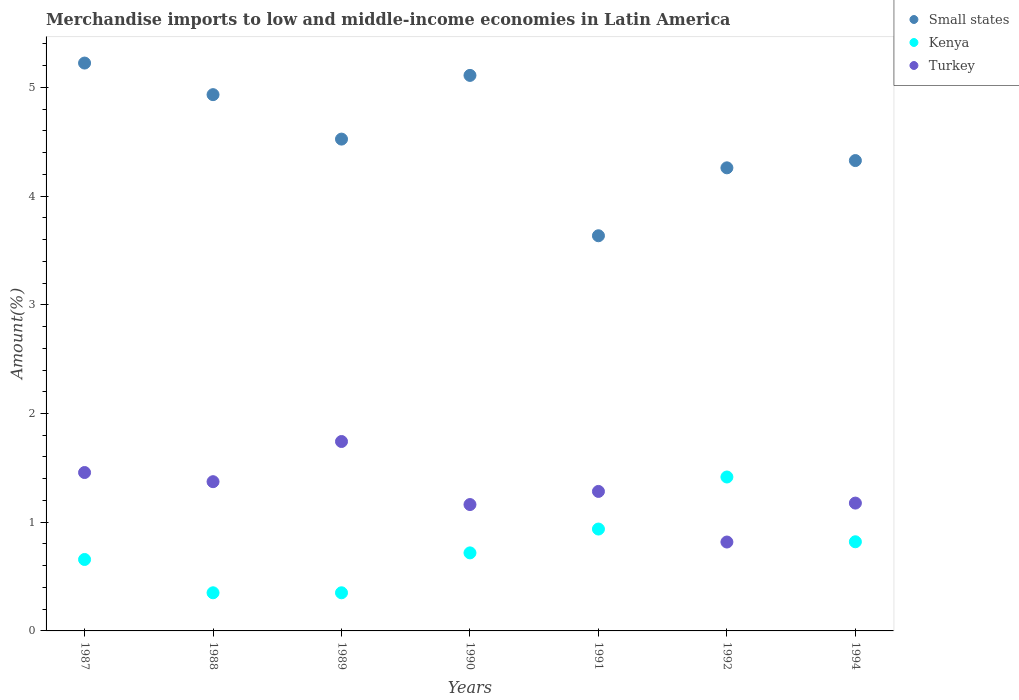How many different coloured dotlines are there?
Keep it short and to the point. 3. Is the number of dotlines equal to the number of legend labels?
Give a very brief answer. Yes. What is the percentage of amount earned from merchandise imports in Turkey in 1991?
Make the answer very short. 1.28. Across all years, what is the maximum percentage of amount earned from merchandise imports in Small states?
Your answer should be very brief. 5.22. Across all years, what is the minimum percentage of amount earned from merchandise imports in Turkey?
Your response must be concise. 0.82. In which year was the percentage of amount earned from merchandise imports in Turkey maximum?
Your answer should be compact. 1989. In which year was the percentage of amount earned from merchandise imports in Kenya minimum?
Keep it short and to the point. 1988. What is the total percentage of amount earned from merchandise imports in Kenya in the graph?
Provide a short and direct response. 5.25. What is the difference between the percentage of amount earned from merchandise imports in Kenya in 1987 and that in 1989?
Make the answer very short. 0.31. What is the difference between the percentage of amount earned from merchandise imports in Turkey in 1994 and the percentage of amount earned from merchandise imports in Kenya in 1990?
Give a very brief answer. 0.46. What is the average percentage of amount earned from merchandise imports in Kenya per year?
Offer a terse response. 0.75. In the year 1991, what is the difference between the percentage of amount earned from merchandise imports in Turkey and percentage of amount earned from merchandise imports in Small states?
Make the answer very short. -2.35. What is the ratio of the percentage of amount earned from merchandise imports in Turkey in 1990 to that in 1992?
Give a very brief answer. 1.42. Is the percentage of amount earned from merchandise imports in Kenya in 1987 less than that in 1989?
Ensure brevity in your answer.  No. What is the difference between the highest and the second highest percentage of amount earned from merchandise imports in Small states?
Offer a terse response. 0.11. What is the difference between the highest and the lowest percentage of amount earned from merchandise imports in Small states?
Keep it short and to the point. 1.59. Is the sum of the percentage of amount earned from merchandise imports in Small states in 1992 and 1994 greater than the maximum percentage of amount earned from merchandise imports in Kenya across all years?
Offer a terse response. Yes. Is it the case that in every year, the sum of the percentage of amount earned from merchandise imports in Kenya and percentage of amount earned from merchandise imports in Turkey  is greater than the percentage of amount earned from merchandise imports in Small states?
Offer a very short reply. No. Is the percentage of amount earned from merchandise imports in Kenya strictly greater than the percentage of amount earned from merchandise imports in Small states over the years?
Provide a succinct answer. No. What is the difference between two consecutive major ticks on the Y-axis?
Give a very brief answer. 1. Does the graph contain any zero values?
Offer a terse response. No. Where does the legend appear in the graph?
Offer a very short reply. Top right. How many legend labels are there?
Ensure brevity in your answer.  3. What is the title of the graph?
Provide a succinct answer. Merchandise imports to low and middle-income economies in Latin America. Does "French Polynesia" appear as one of the legend labels in the graph?
Your response must be concise. No. What is the label or title of the Y-axis?
Ensure brevity in your answer.  Amount(%). What is the Amount(%) of Small states in 1987?
Your response must be concise. 5.22. What is the Amount(%) in Kenya in 1987?
Ensure brevity in your answer.  0.66. What is the Amount(%) of Turkey in 1987?
Give a very brief answer. 1.46. What is the Amount(%) in Small states in 1988?
Provide a short and direct response. 4.93. What is the Amount(%) of Kenya in 1988?
Keep it short and to the point. 0.35. What is the Amount(%) of Turkey in 1988?
Offer a terse response. 1.37. What is the Amount(%) of Small states in 1989?
Offer a very short reply. 4.52. What is the Amount(%) of Kenya in 1989?
Give a very brief answer. 0.35. What is the Amount(%) in Turkey in 1989?
Provide a succinct answer. 1.74. What is the Amount(%) of Small states in 1990?
Provide a succinct answer. 5.11. What is the Amount(%) of Kenya in 1990?
Your response must be concise. 0.72. What is the Amount(%) in Turkey in 1990?
Offer a very short reply. 1.16. What is the Amount(%) of Small states in 1991?
Your response must be concise. 3.64. What is the Amount(%) in Kenya in 1991?
Your answer should be compact. 0.94. What is the Amount(%) of Turkey in 1991?
Provide a short and direct response. 1.28. What is the Amount(%) in Small states in 1992?
Your response must be concise. 4.26. What is the Amount(%) in Kenya in 1992?
Provide a short and direct response. 1.42. What is the Amount(%) of Turkey in 1992?
Your response must be concise. 0.82. What is the Amount(%) of Small states in 1994?
Make the answer very short. 4.33. What is the Amount(%) in Kenya in 1994?
Your answer should be very brief. 0.82. What is the Amount(%) in Turkey in 1994?
Offer a very short reply. 1.18. Across all years, what is the maximum Amount(%) in Small states?
Ensure brevity in your answer.  5.22. Across all years, what is the maximum Amount(%) of Kenya?
Your answer should be compact. 1.42. Across all years, what is the maximum Amount(%) of Turkey?
Your answer should be compact. 1.74. Across all years, what is the minimum Amount(%) of Small states?
Ensure brevity in your answer.  3.64. Across all years, what is the minimum Amount(%) of Kenya?
Provide a succinct answer. 0.35. Across all years, what is the minimum Amount(%) in Turkey?
Provide a short and direct response. 0.82. What is the total Amount(%) in Small states in the graph?
Provide a succinct answer. 32.01. What is the total Amount(%) of Kenya in the graph?
Keep it short and to the point. 5.25. What is the total Amount(%) of Turkey in the graph?
Provide a succinct answer. 9.01. What is the difference between the Amount(%) in Small states in 1987 and that in 1988?
Your answer should be very brief. 0.29. What is the difference between the Amount(%) of Kenya in 1987 and that in 1988?
Make the answer very short. 0.31. What is the difference between the Amount(%) of Turkey in 1987 and that in 1988?
Ensure brevity in your answer.  0.08. What is the difference between the Amount(%) in Small states in 1987 and that in 1989?
Give a very brief answer. 0.7. What is the difference between the Amount(%) in Kenya in 1987 and that in 1989?
Make the answer very short. 0.31. What is the difference between the Amount(%) in Turkey in 1987 and that in 1989?
Your response must be concise. -0.29. What is the difference between the Amount(%) in Small states in 1987 and that in 1990?
Keep it short and to the point. 0.11. What is the difference between the Amount(%) of Kenya in 1987 and that in 1990?
Keep it short and to the point. -0.06. What is the difference between the Amount(%) in Turkey in 1987 and that in 1990?
Your answer should be compact. 0.29. What is the difference between the Amount(%) of Small states in 1987 and that in 1991?
Your answer should be very brief. 1.59. What is the difference between the Amount(%) in Kenya in 1987 and that in 1991?
Give a very brief answer. -0.28. What is the difference between the Amount(%) of Turkey in 1987 and that in 1991?
Your answer should be compact. 0.17. What is the difference between the Amount(%) of Small states in 1987 and that in 1992?
Your answer should be compact. 0.96. What is the difference between the Amount(%) in Kenya in 1987 and that in 1992?
Offer a terse response. -0.76. What is the difference between the Amount(%) of Turkey in 1987 and that in 1992?
Make the answer very short. 0.64. What is the difference between the Amount(%) in Small states in 1987 and that in 1994?
Offer a very short reply. 0.9. What is the difference between the Amount(%) of Kenya in 1987 and that in 1994?
Make the answer very short. -0.16. What is the difference between the Amount(%) in Turkey in 1987 and that in 1994?
Offer a terse response. 0.28. What is the difference between the Amount(%) in Small states in 1988 and that in 1989?
Your answer should be very brief. 0.41. What is the difference between the Amount(%) of Kenya in 1988 and that in 1989?
Ensure brevity in your answer.  -0. What is the difference between the Amount(%) of Turkey in 1988 and that in 1989?
Offer a very short reply. -0.37. What is the difference between the Amount(%) of Small states in 1988 and that in 1990?
Keep it short and to the point. -0.18. What is the difference between the Amount(%) of Kenya in 1988 and that in 1990?
Give a very brief answer. -0.37. What is the difference between the Amount(%) of Turkey in 1988 and that in 1990?
Offer a terse response. 0.21. What is the difference between the Amount(%) in Small states in 1988 and that in 1991?
Your response must be concise. 1.3. What is the difference between the Amount(%) of Kenya in 1988 and that in 1991?
Ensure brevity in your answer.  -0.59. What is the difference between the Amount(%) of Turkey in 1988 and that in 1991?
Your answer should be compact. 0.09. What is the difference between the Amount(%) of Small states in 1988 and that in 1992?
Provide a short and direct response. 0.67. What is the difference between the Amount(%) in Kenya in 1988 and that in 1992?
Ensure brevity in your answer.  -1.07. What is the difference between the Amount(%) in Turkey in 1988 and that in 1992?
Make the answer very short. 0.56. What is the difference between the Amount(%) of Small states in 1988 and that in 1994?
Offer a terse response. 0.61. What is the difference between the Amount(%) of Kenya in 1988 and that in 1994?
Ensure brevity in your answer.  -0.47. What is the difference between the Amount(%) of Turkey in 1988 and that in 1994?
Make the answer very short. 0.2. What is the difference between the Amount(%) of Small states in 1989 and that in 1990?
Provide a succinct answer. -0.59. What is the difference between the Amount(%) of Kenya in 1989 and that in 1990?
Provide a succinct answer. -0.37. What is the difference between the Amount(%) of Turkey in 1989 and that in 1990?
Your answer should be compact. 0.58. What is the difference between the Amount(%) in Small states in 1989 and that in 1991?
Give a very brief answer. 0.89. What is the difference between the Amount(%) of Kenya in 1989 and that in 1991?
Give a very brief answer. -0.59. What is the difference between the Amount(%) of Turkey in 1989 and that in 1991?
Keep it short and to the point. 0.46. What is the difference between the Amount(%) in Small states in 1989 and that in 1992?
Give a very brief answer. 0.26. What is the difference between the Amount(%) of Kenya in 1989 and that in 1992?
Your response must be concise. -1.07. What is the difference between the Amount(%) in Turkey in 1989 and that in 1992?
Make the answer very short. 0.92. What is the difference between the Amount(%) of Small states in 1989 and that in 1994?
Your answer should be compact. 0.2. What is the difference between the Amount(%) in Kenya in 1989 and that in 1994?
Your response must be concise. -0.47. What is the difference between the Amount(%) of Turkey in 1989 and that in 1994?
Your answer should be compact. 0.57. What is the difference between the Amount(%) of Small states in 1990 and that in 1991?
Your response must be concise. 1.48. What is the difference between the Amount(%) of Kenya in 1990 and that in 1991?
Keep it short and to the point. -0.22. What is the difference between the Amount(%) of Turkey in 1990 and that in 1991?
Make the answer very short. -0.12. What is the difference between the Amount(%) in Small states in 1990 and that in 1992?
Provide a short and direct response. 0.85. What is the difference between the Amount(%) of Kenya in 1990 and that in 1992?
Ensure brevity in your answer.  -0.7. What is the difference between the Amount(%) in Turkey in 1990 and that in 1992?
Offer a very short reply. 0.34. What is the difference between the Amount(%) of Small states in 1990 and that in 1994?
Make the answer very short. 0.78. What is the difference between the Amount(%) of Kenya in 1990 and that in 1994?
Keep it short and to the point. -0.1. What is the difference between the Amount(%) of Turkey in 1990 and that in 1994?
Give a very brief answer. -0.01. What is the difference between the Amount(%) of Small states in 1991 and that in 1992?
Provide a short and direct response. -0.62. What is the difference between the Amount(%) of Kenya in 1991 and that in 1992?
Offer a very short reply. -0.48. What is the difference between the Amount(%) in Turkey in 1991 and that in 1992?
Your answer should be very brief. 0.47. What is the difference between the Amount(%) in Small states in 1991 and that in 1994?
Give a very brief answer. -0.69. What is the difference between the Amount(%) in Kenya in 1991 and that in 1994?
Provide a short and direct response. 0.12. What is the difference between the Amount(%) in Turkey in 1991 and that in 1994?
Your answer should be compact. 0.11. What is the difference between the Amount(%) of Small states in 1992 and that in 1994?
Offer a very short reply. -0.07. What is the difference between the Amount(%) in Kenya in 1992 and that in 1994?
Keep it short and to the point. 0.6. What is the difference between the Amount(%) of Turkey in 1992 and that in 1994?
Your answer should be compact. -0.36. What is the difference between the Amount(%) in Small states in 1987 and the Amount(%) in Kenya in 1988?
Offer a very short reply. 4.87. What is the difference between the Amount(%) of Small states in 1987 and the Amount(%) of Turkey in 1988?
Offer a very short reply. 3.85. What is the difference between the Amount(%) of Kenya in 1987 and the Amount(%) of Turkey in 1988?
Keep it short and to the point. -0.72. What is the difference between the Amount(%) in Small states in 1987 and the Amount(%) in Kenya in 1989?
Provide a short and direct response. 4.87. What is the difference between the Amount(%) of Small states in 1987 and the Amount(%) of Turkey in 1989?
Keep it short and to the point. 3.48. What is the difference between the Amount(%) in Kenya in 1987 and the Amount(%) in Turkey in 1989?
Keep it short and to the point. -1.09. What is the difference between the Amount(%) of Small states in 1987 and the Amount(%) of Kenya in 1990?
Offer a very short reply. 4.51. What is the difference between the Amount(%) in Small states in 1987 and the Amount(%) in Turkey in 1990?
Make the answer very short. 4.06. What is the difference between the Amount(%) of Kenya in 1987 and the Amount(%) of Turkey in 1990?
Keep it short and to the point. -0.51. What is the difference between the Amount(%) of Small states in 1987 and the Amount(%) of Kenya in 1991?
Provide a short and direct response. 4.29. What is the difference between the Amount(%) of Small states in 1987 and the Amount(%) of Turkey in 1991?
Your answer should be very brief. 3.94. What is the difference between the Amount(%) of Kenya in 1987 and the Amount(%) of Turkey in 1991?
Give a very brief answer. -0.63. What is the difference between the Amount(%) in Small states in 1987 and the Amount(%) in Kenya in 1992?
Keep it short and to the point. 3.81. What is the difference between the Amount(%) in Small states in 1987 and the Amount(%) in Turkey in 1992?
Make the answer very short. 4.41. What is the difference between the Amount(%) of Kenya in 1987 and the Amount(%) of Turkey in 1992?
Keep it short and to the point. -0.16. What is the difference between the Amount(%) in Small states in 1987 and the Amount(%) in Kenya in 1994?
Your response must be concise. 4.4. What is the difference between the Amount(%) of Small states in 1987 and the Amount(%) of Turkey in 1994?
Offer a very short reply. 4.05. What is the difference between the Amount(%) of Kenya in 1987 and the Amount(%) of Turkey in 1994?
Provide a succinct answer. -0.52. What is the difference between the Amount(%) of Small states in 1988 and the Amount(%) of Kenya in 1989?
Provide a succinct answer. 4.58. What is the difference between the Amount(%) of Small states in 1988 and the Amount(%) of Turkey in 1989?
Offer a very short reply. 3.19. What is the difference between the Amount(%) of Kenya in 1988 and the Amount(%) of Turkey in 1989?
Offer a terse response. -1.39. What is the difference between the Amount(%) of Small states in 1988 and the Amount(%) of Kenya in 1990?
Make the answer very short. 4.22. What is the difference between the Amount(%) in Small states in 1988 and the Amount(%) in Turkey in 1990?
Your response must be concise. 3.77. What is the difference between the Amount(%) in Kenya in 1988 and the Amount(%) in Turkey in 1990?
Your answer should be very brief. -0.81. What is the difference between the Amount(%) of Small states in 1988 and the Amount(%) of Kenya in 1991?
Provide a succinct answer. 4. What is the difference between the Amount(%) in Small states in 1988 and the Amount(%) in Turkey in 1991?
Offer a very short reply. 3.65. What is the difference between the Amount(%) in Kenya in 1988 and the Amount(%) in Turkey in 1991?
Give a very brief answer. -0.93. What is the difference between the Amount(%) of Small states in 1988 and the Amount(%) of Kenya in 1992?
Ensure brevity in your answer.  3.52. What is the difference between the Amount(%) of Small states in 1988 and the Amount(%) of Turkey in 1992?
Keep it short and to the point. 4.12. What is the difference between the Amount(%) of Kenya in 1988 and the Amount(%) of Turkey in 1992?
Your response must be concise. -0.47. What is the difference between the Amount(%) of Small states in 1988 and the Amount(%) of Kenya in 1994?
Your answer should be very brief. 4.11. What is the difference between the Amount(%) of Small states in 1988 and the Amount(%) of Turkey in 1994?
Offer a terse response. 3.76. What is the difference between the Amount(%) in Kenya in 1988 and the Amount(%) in Turkey in 1994?
Ensure brevity in your answer.  -0.83. What is the difference between the Amount(%) in Small states in 1989 and the Amount(%) in Kenya in 1990?
Offer a very short reply. 3.81. What is the difference between the Amount(%) of Small states in 1989 and the Amount(%) of Turkey in 1990?
Your response must be concise. 3.36. What is the difference between the Amount(%) in Kenya in 1989 and the Amount(%) in Turkey in 1990?
Offer a very short reply. -0.81. What is the difference between the Amount(%) of Small states in 1989 and the Amount(%) of Kenya in 1991?
Your answer should be compact. 3.59. What is the difference between the Amount(%) of Small states in 1989 and the Amount(%) of Turkey in 1991?
Provide a short and direct response. 3.24. What is the difference between the Amount(%) of Kenya in 1989 and the Amount(%) of Turkey in 1991?
Your response must be concise. -0.93. What is the difference between the Amount(%) in Small states in 1989 and the Amount(%) in Kenya in 1992?
Ensure brevity in your answer.  3.11. What is the difference between the Amount(%) in Small states in 1989 and the Amount(%) in Turkey in 1992?
Offer a very short reply. 3.71. What is the difference between the Amount(%) of Kenya in 1989 and the Amount(%) of Turkey in 1992?
Offer a very short reply. -0.47. What is the difference between the Amount(%) of Small states in 1989 and the Amount(%) of Kenya in 1994?
Offer a very short reply. 3.7. What is the difference between the Amount(%) of Small states in 1989 and the Amount(%) of Turkey in 1994?
Provide a short and direct response. 3.35. What is the difference between the Amount(%) in Kenya in 1989 and the Amount(%) in Turkey in 1994?
Make the answer very short. -0.83. What is the difference between the Amount(%) of Small states in 1990 and the Amount(%) of Kenya in 1991?
Your answer should be very brief. 4.17. What is the difference between the Amount(%) of Small states in 1990 and the Amount(%) of Turkey in 1991?
Your response must be concise. 3.83. What is the difference between the Amount(%) of Kenya in 1990 and the Amount(%) of Turkey in 1991?
Your response must be concise. -0.57. What is the difference between the Amount(%) of Small states in 1990 and the Amount(%) of Kenya in 1992?
Give a very brief answer. 3.69. What is the difference between the Amount(%) in Small states in 1990 and the Amount(%) in Turkey in 1992?
Offer a terse response. 4.29. What is the difference between the Amount(%) in Kenya in 1990 and the Amount(%) in Turkey in 1992?
Provide a succinct answer. -0.1. What is the difference between the Amount(%) of Small states in 1990 and the Amount(%) of Kenya in 1994?
Give a very brief answer. 4.29. What is the difference between the Amount(%) of Small states in 1990 and the Amount(%) of Turkey in 1994?
Provide a succinct answer. 3.93. What is the difference between the Amount(%) in Kenya in 1990 and the Amount(%) in Turkey in 1994?
Your answer should be very brief. -0.46. What is the difference between the Amount(%) of Small states in 1991 and the Amount(%) of Kenya in 1992?
Ensure brevity in your answer.  2.22. What is the difference between the Amount(%) in Small states in 1991 and the Amount(%) in Turkey in 1992?
Your response must be concise. 2.82. What is the difference between the Amount(%) in Kenya in 1991 and the Amount(%) in Turkey in 1992?
Your answer should be very brief. 0.12. What is the difference between the Amount(%) in Small states in 1991 and the Amount(%) in Kenya in 1994?
Ensure brevity in your answer.  2.82. What is the difference between the Amount(%) in Small states in 1991 and the Amount(%) in Turkey in 1994?
Make the answer very short. 2.46. What is the difference between the Amount(%) in Kenya in 1991 and the Amount(%) in Turkey in 1994?
Ensure brevity in your answer.  -0.24. What is the difference between the Amount(%) of Small states in 1992 and the Amount(%) of Kenya in 1994?
Your response must be concise. 3.44. What is the difference between the Amount(%) of Small states in 1992 and the Amount(%) of Turkey in 1994?
Offer a very short reply. 3.08. What is the difference between the Amount(%) in Kenya in 1992 and the Amount(%) in Turkey in 1994?
Your response must be concise. 0.24. What is the average Amount(%) of Small states per year?
Keep it short and to the point. 4.57. What is the average Amount(%) in Kenya per year?
Provide a succinct answer. 0.75. What is the average Amount(%) of Turkey per year?
Give a very brief answer. 1.29. In the year 1987, what is the difference between the Amount(%) in Small states and Amount(%) in Kenya?
Your response must be concise. 4.57. In the year 1987, what is the difference between the Amount(%) of Small states and Amount(%) of Turkey?
Provide a succinct answer. 3.77. In the year 1987, what is the difference between the Amount(%) in Kenya and Amount(%) in Turkey?
Provide a succinct answer. -0.8. In the year 1988, what is the difference between the Amount(%) in Small states and Amount(%) in Kenya?
Your response must be concise. 4.58. In the year 1988, what is the difference between the Amount(%) in Small states and Amount(%) in Turkey?
Provide a succinct answer. 3.56. In the year 1988, what is the difference between the Amount(%) of Kenya and Amount(%) of Turkey?
Make the answer very short. -1.02. In the year 1989, what is the difference between the Amount(%) in Small states and Amount(%) in Kenya?
Ensure brevity in your answer.  4.17. In the year 1989, what is the difference between the Amount(%) of Small states and Amount(%) of Turkey?
Give a very brief answer. 2.78. In the year 1989, what is the difference between the Amount(%) of Kenya and Amount(%) of Turkey?
Your response must be concise. -1.39. In the year 1990, what is the difference between the Amount(%) in Small states and Amount(%) in Kenya?
Make the answer very short. 4.39. In the year 1990, what is the difference between the Amount(%) of Small states and Amount(%) of Turkey?
Provide a succinct answer. 3.95. In the year 1990, what is the difference between the Amount(%) of Kenya and Amount(%) of Turkey?
Ensure brevity in your answer.  -0.44. In the year 1991, what is the difference between the Amount(%) in Small states and Amount(%) in Kenya?
Provide a succinct answer. 2.7. In the year 1991, what is the difference between the Amount(%) of Small states and Amount(%) of Turkey?
Give a very brief answer. 2.35. In the year 1991, what is the difference between the Amount(%) in Kenya and Amount(%) in Turkey?
Give a very brief answer. -0.35. In the year 1992, what is the difference between the Amount(%) of Small states and Amount(%) of Kenya?
Offer a terse response. 2.84. In the year 1992, what is the difference between the Amount(%) of Small states and Amount(%) of Turkey?
Make the answer very short. 3.44. In the year 1992, what is the difference between the Amount(%) in Kenya and Amount(%) in Turkey?
Give a very brief answer. 0.6. In the year 1994, what is the difference between the Amount(%) of Small states and Amount(%) of Kenya?
Ensure brevity in your answer.  3.51. In the year 1994, what is the difference between the Amount(%) in Small states and Amount(%) in Turkey?
Offer a very short reply. 3.15. In the year 1994, what is the difference between the Amount(%) in Kenya and Amount(%) in Turkey?
Your answer should be very brief. -0.36. What is the ratio of the Amount(%) in Small states in 1987 to that in 1988?
Give a very brief answer. 1.06. What is the ratio of the Amount(%) of Kenya in 1987 to that in 1988?
Make the answer very short. 1.87. What is the ratio of the Amount(%) in Turkey in 1987 to that in 1988?
Offer a terse response. 1.06. What is the ratio of the Amount(%) in Small states in 1987 to that in 1989?
Provide a short and direct response. 1.15. What is the ratio of the Amount(%) of Kenya in 1987 to that in 1989?
Ensure brevity in your answer.  1.87. What is the ratio of the Amount(%) in Turkey in 1987 to that in 1989?
Give a very brief answer. 0.84. What is the ratio of the Amount(%) of Small states in 1987 to that in 1990?
Your answer should be compact. 1.02. What is the ratio of the Amount(%) of Kenya in 1987 to that in 1990?
Ensure brevity in your answer.  0.92. What is the ratio of the Amount(%) of Turkey in 1987 to that in 1990?
Offer a very short reply. 1.25. What is the ratio of the Amount(%) in Small states in 1987 to that in 1991?
Provide a short and direct response. 1.44. What is the ratio of the Amount(%) in Kenya in 1987 to that in 1991?
Keep it short and to the point. 0.7. What is the ratio of the Amount(%) in Turkey in 1987 to that in 1991?
Provide a short and direct response. 1.14. What is the ratio of the Amount(%) of Small states in 1987 to that in 1992?
Give a very brief answer. 1.23. What is the ratio of the Amount(%) in Kenya in 1987 to that in 1992?
Provide a short and direct response. 0.46. What is the ratio of the Amount(%) of Turkey in 1987 to that in 1992?
Provide a short and direct response. 1.78. What is the ratio of the Amount(%) of Small states in 1987 to that in 1994?
Give a very brief answer. 1.21. What is the ratio of the Amount(%) in Kenya in 1987 to that in 1994?
Give a very brief answer. 0.8. What is the ratio of the Amount(%) in Turkey in 1987 to that in 1994?
Make the answer very short. 1.24. What is the ratio of the Amount(%) of Small states in 1988 to that in 1989?
Your response must be concise. 1.09. What is the ratio of the Amount(%) of Turkey in 1988 to that in 1989?
Give a very brief answer. 0.79. What is the ratio of the Amount(%) of Small states in 1988 to that in 1990?
Your answer should be very brief. 0.97. What is the ratio of the Amount(%) in Kenya in 1988 to that in 1990?
Keep it short and to the point. 0.49. What is the ratio of the Amount(%) in Turkey in 1988 to that in 1990?
Provide a succinct answer. 1.18. What is the ratio of the Amount(%) in Small states in 1988 to that in 1991?
Your answer should be very brief. 1.36. What is the ratio of the Amount(%) of Kenya in 1988 to that in 1991?
Offer a very short reply. 0.37. What is the ratio of the Amount(%) in Turkey in 1988 to that in 1991?
Keep it short and to the point. 1.07. What is the ratio of the Amount(%) in Small states in 1988 to that in 1992?
Offer a very short reply. 1.16. What is the ratio of the Amount(%) in Kenya in 1988 to that in 1992?
Offer a terse response. 0.25. What is the ratio of the Amount(%) in Turkey in 1988 to that in 1992?
Provide a short and direct response. 1.68. What is the ratio of the Amount(%) of Small states in 1988 to that in 1994?
Ensure brevity in your answer.  1.14. What is the ratio of the Amount(%) of Kenya in 1988 to that in 1994?
Provide a short and direct response. 0.43. What is the ratio of the Amount(%) in Turkey in 1988 to that in 1994?
Provide a succinct answer. 1.17. What is the ratio of the Amount(%) of Small states in 1989 to that in 1990?
Offer a very short reply. 0.89. What is the ratio of the Amount(%) in Kenya in 1989 to that in 1990?
Offer a very short reply. 0.49. What is the ratio of the Amount(%) in Turkey in 1989 to that in 1990?
Ensure brevity in your answer.  1.5. What is the ratio of the Amount(%) of Small states in 1989 to that in 1991?
Ensure brevity in your answer.  1.24. What is the ratio of the Amount(%) in Kenya in 1989 to that in 1991?
Provide a succinct answer. 0.37. What is the ratio of the Amount(%) in Turkey in 1989 to that in 1991?
Give a very brief answer. 1.36. What is the ratio of the Amount(%) of Small states in 1989 to that in 1992?
Offer a very short reply. 1.06. What is the ratio of the Amount(%) in Kenya in 1989 to that in 1992?
Provide a short and direct response. 0.25. What is the ratio of the Amount(%) of Turkey in 1989 to that in 1992?
Offer a terse response. 2.13. What is the ratio of the Amount(%) of Small states in 1989 to that in 1994?
Your response must be concise. 1.05. What is the ratio of the Amount(%) in Kenya in 1989 to that in 1994?
Make the answer very short. 0.43. What is the ratio of the Amount(%) of Turkey in 1989 to that in 1994?
Give a very brief answer. 1.48. What is the ratio of the Amount(%) of Small states in 1990 to that in 1991?
Make the answer very short. 1.41. What is the ratio of the Amount(%) of Kenya in 1990 to that in 1991?
Make the answer very short. 0.77. What is the ratio of the Amount(%) in Turkey in 1990 to that in 1991?
Your answer should be very brief. 0.91. What is the ratio of the Amount(%) in Small states in 1990 to that in 1992?
Give a very brief answer. 1.2. What is the ratio of the Amount(%) in Kenya in 1990 to that in 1992?
Your response must be concise. 0.51. What is the ratio of the Amount(%) in Turkey in 1990 to that in 1992?
Ensure brevity in your answer.  1.42. What is the ratio of the Amount(%) in Small states in 1990 to that in 1994?
Make the answer very short. 1.18. What is the ratio of the Amount(%) of Kenya in 1990 to that in 1994?
Ensure brevity in your answer.  0.88. What is the ratio of the Amount(%) of Turkey in 1990 to that in 1994?
Offer a very short reply. 0.99. What is the ratio of the Amount(%) in Small states in 1991 to that in 1992?
Ensure brevity in your answer.  0.85. What is the ratio of the Amount(%) of Kenya in 1991 to that in 1992?
Keep it short and to the point. 0.66. What is the ratio of the Amount(%) in Turkey in 1991 to that in 1992?
Offer a terse response. 1.57. What is the ratio of the Amount(%) in Small states in 1991 to that in 1994?
Offer a very short reply. 0.84. What is the ratio of the Amount(%) of Kenya in 1991 to that in 1994?
Provide a short and direct response. 1.14. What is the ratio of the Amount(%) of Turkey in 1991 to that in 1994?
Your answer should be compact. 1.09. What is the ratio of the Amount(%) in Small states in 1992 to that in 1994?
Offer a terse response. 0.98. What is the ratio of the Amount(%) of Kenya in 1992 to that in 1994?
Keep it short and to the point. 1.73. What is the ratio of the Amount(%) of Turkey in 1992 to that in 1994?
Give a very brief answer. 0.7. What is the difference between the highest and the second highest Amount(%) of Small states?
Your answer should be very brief. 0.11. What is the difference between the highest and the second highest Amount(%) in Kenya?
Offer a very short reply. 0.48. What is the difference between the highest and the second highest Amount(%) in Turkey?
Keep it short and to the point. 0.29. What is the difference between the highest and the lowest Amount(%) in Small states?
Your response must be concise. 1.59. What is the difference between the highest and the lowest Amount(%) in Kenya?
Give a very brief answer. 1.07. What is the difference between the highest and the lowest Amount(%) of Turkey?
Keep it short and to the point. 0.92. 